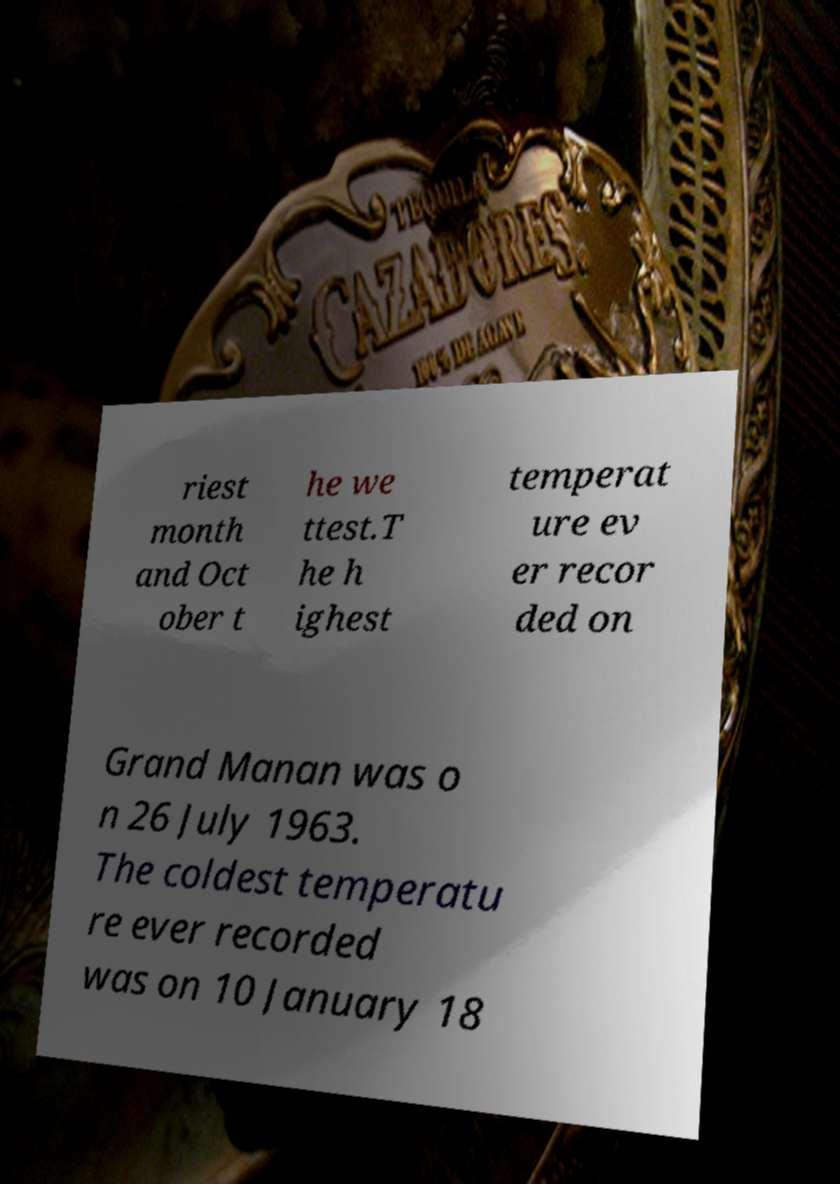Please identify and transcribe the text found in this image. riest month and Oct ober t he we ttest.T he h ighest temperat ure ev er recor ded on Grand Manan was o n 26 July 1963. The coldest temperatu re ever recorded was on 10 January 18 